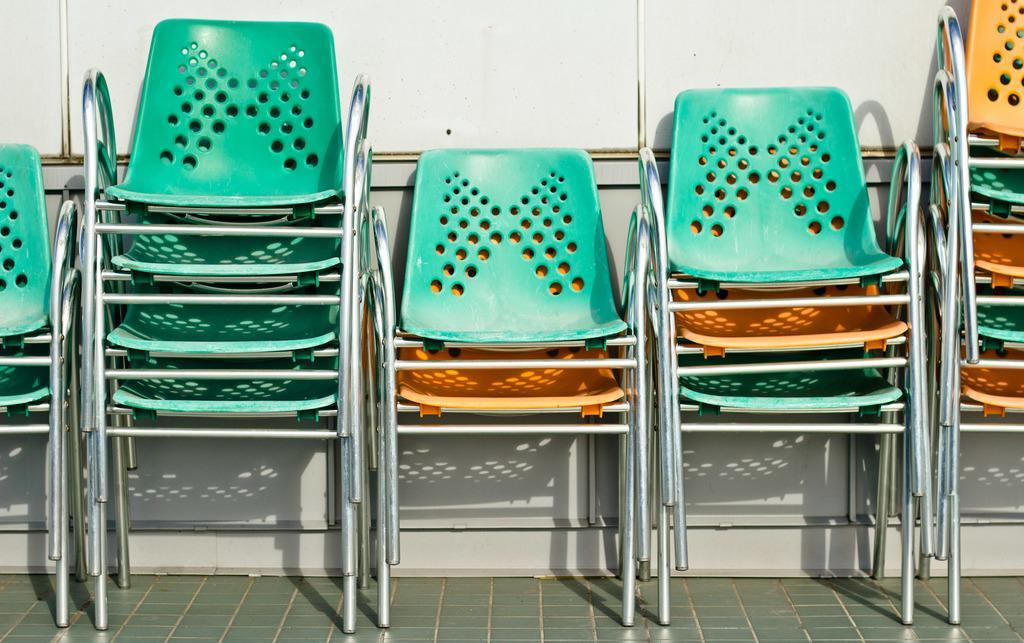In one or two sentences, can you explain what this image depicts? In this image we can see a group of chairs placed one on the other on the floor. On the backside we can see a wall. 